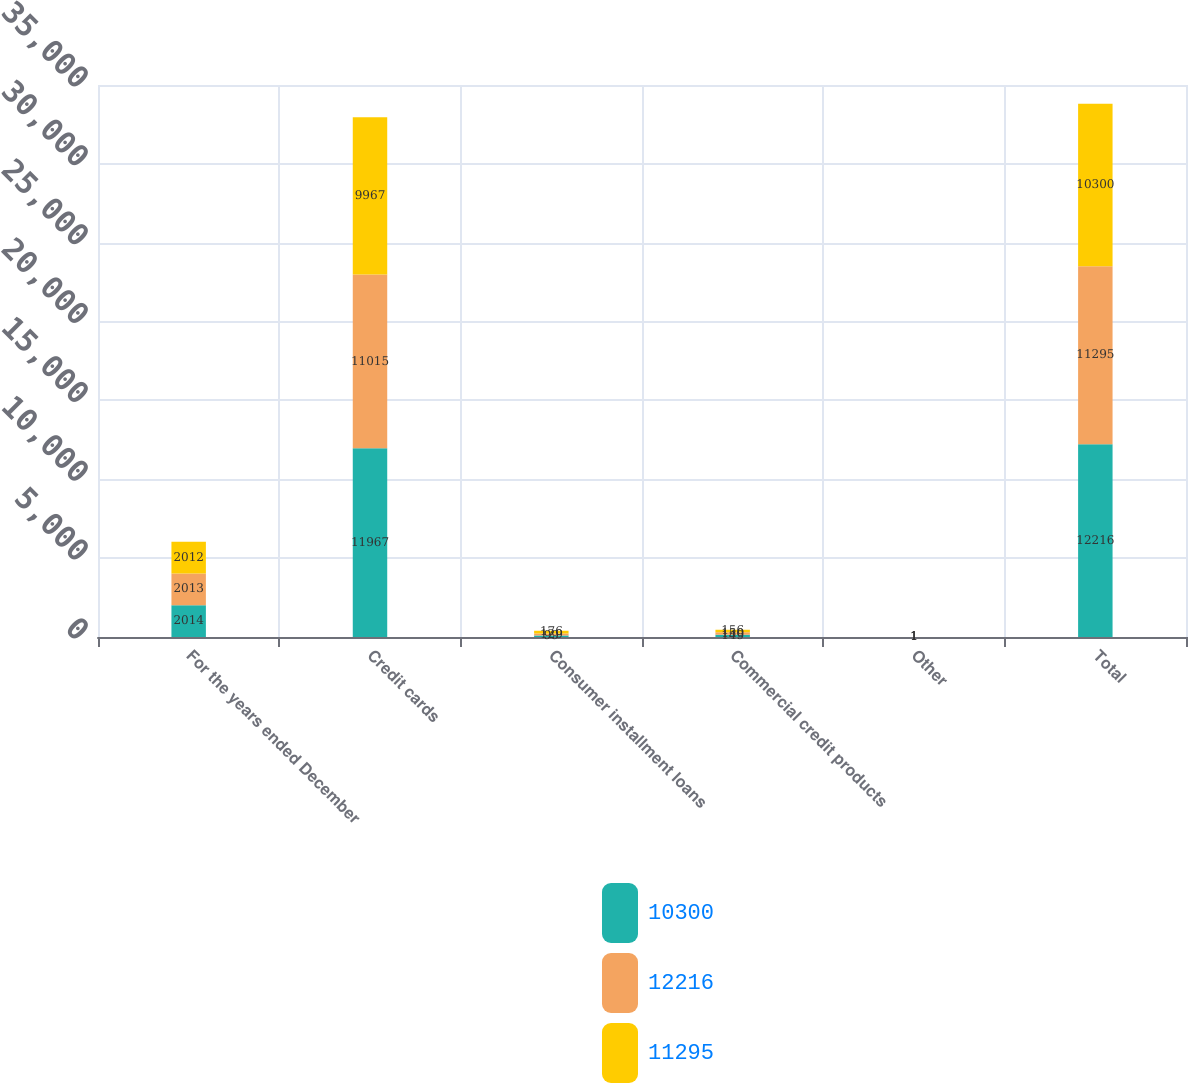<chart> <loc_0><loc_0><loc_500><loc_500><stacked_bar_chart><ecel><fcel>For the years ended December<fcel>Credit cards<fcel>Consumer installment loans<fcel>Commercial credit products<fcel>Other<fcel>Total<nl><fcel>10300<fcel>2014<fcel>11967<fcel>99<fcel>149<fcel>1<fcel>12216<nl><fcel>12216<fcel>2013<fcel>11015<fcel>129<fcel>150<fcel>1<fcel>11295<nl><fcel>11295<fcel>2012<fcel>9967<fcel>176<fcel>156<fcel>1<fcel>10300<nl></chart> 